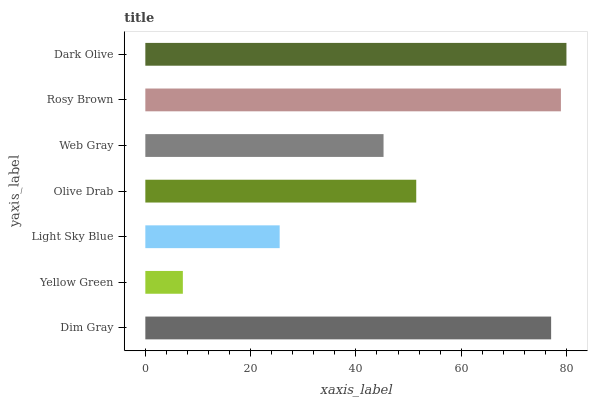Is Yellow Green the minimum?
Answer yes or no. Yes. Is Dark Olive the maximum?
Answer yes or no. Yes. Is Light Sky Blue the minimum?
Answer yes or no. No. Is Light Sky Blue the maximum?
Answer yes or no. No. Is Light Sky Blue greater than Yellow Green?
Answer yes or no. Yes. Is Yellow Green less than Light Sky Blue?
Answer yes or no. Yes. Is Yellow Green greater than Light Sky Blue?
Answer yes or no. No. Is Light Sky Blue less than Yellow Green?
Answer yes or no. No. Is Olive Drab the high median?
Answer yes or no. Yes. Is Olive Drab the low median?
Answer yes or no. Yes. Is Yellow Green the high median?
Answer yes or no. No. Is Rosy Brown the low median?
Answer yes or no. No. 